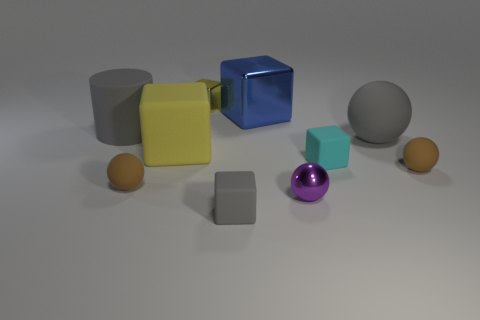Which objects in this image look like they could float on water? The rubber cylinder and the spheres, due to their shape and possible materials, appear like they would be buoyant and able to float on water. 